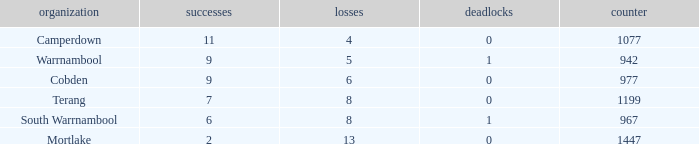What is the draw when the losses were more than 8 and less than 2 wins? None. 